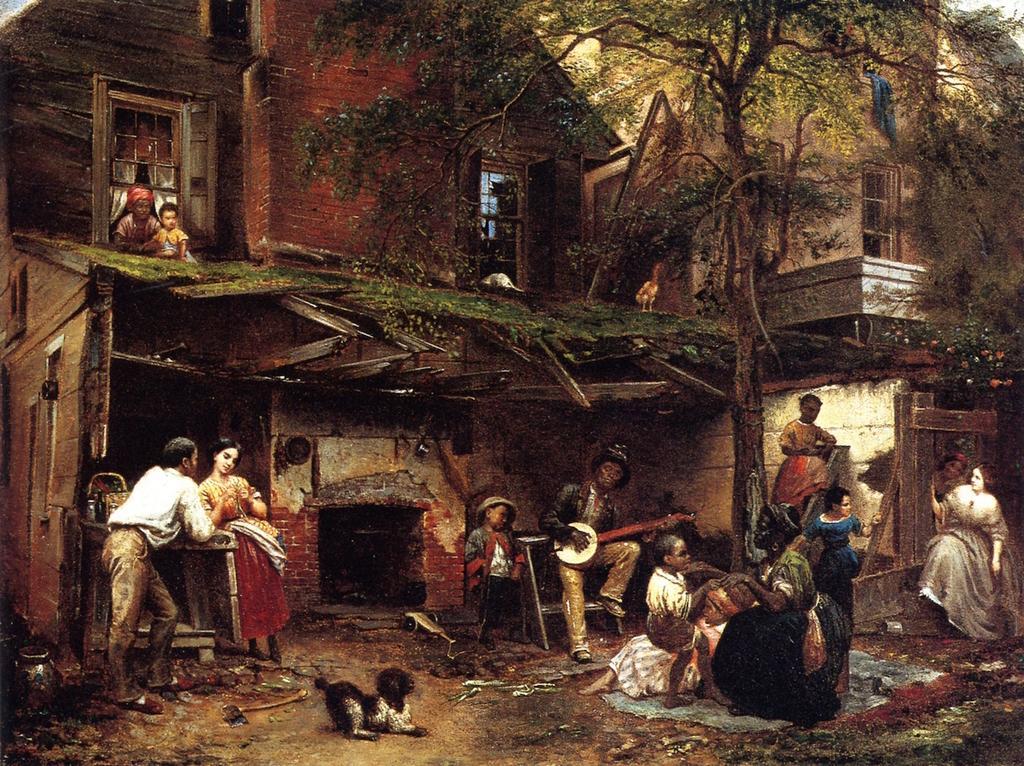Describe this image in one or two sentences. Here we can see an animated picture, in this picture we can see two people standing on the left side, there is a dog here, we can see two buildings and trees here, there are some people sitting here. 